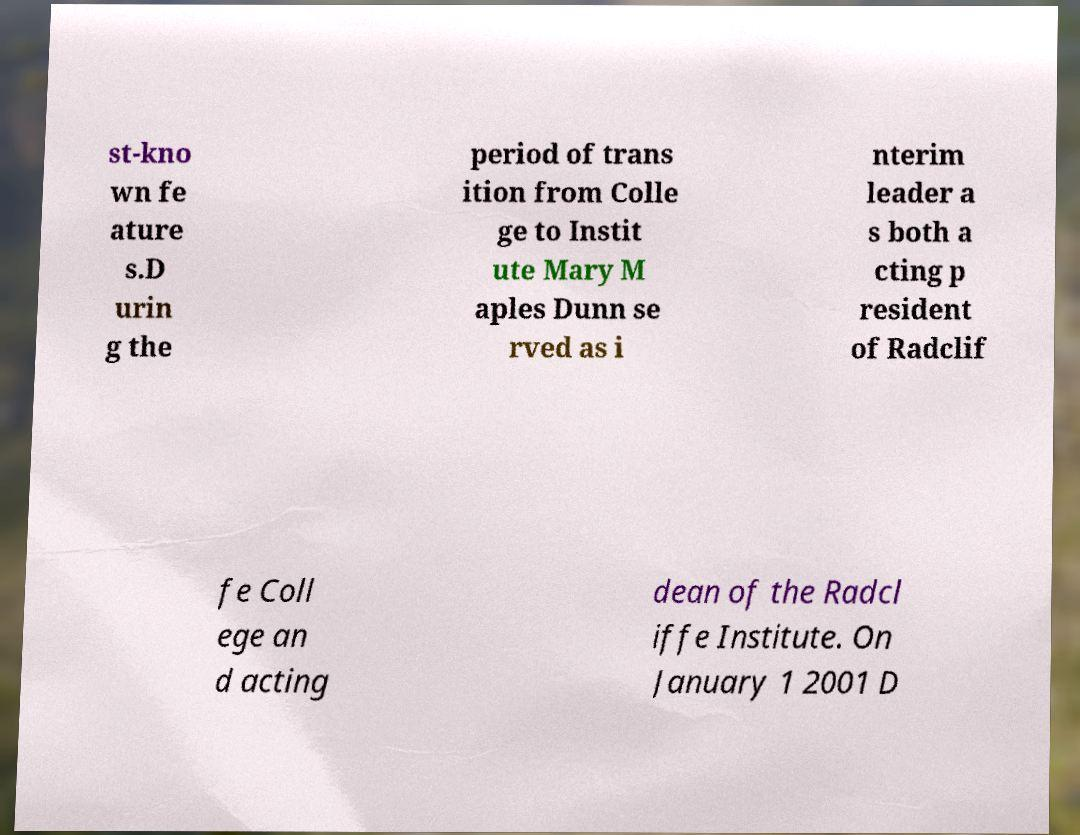Can you read and provide the text displayed in the image?This photo seems to have some interesting text. Can you extract and type it out for me? st-kno wn fe ature s.D urin g the period of trans ition from Colle ge to Instit ute Mary M aples Dunn se rved as i nterim leader a s both a cting p resident of Radclif fe Coll ege an d acting dean of the Radcl iffe Institute. On January 1 2001 D 